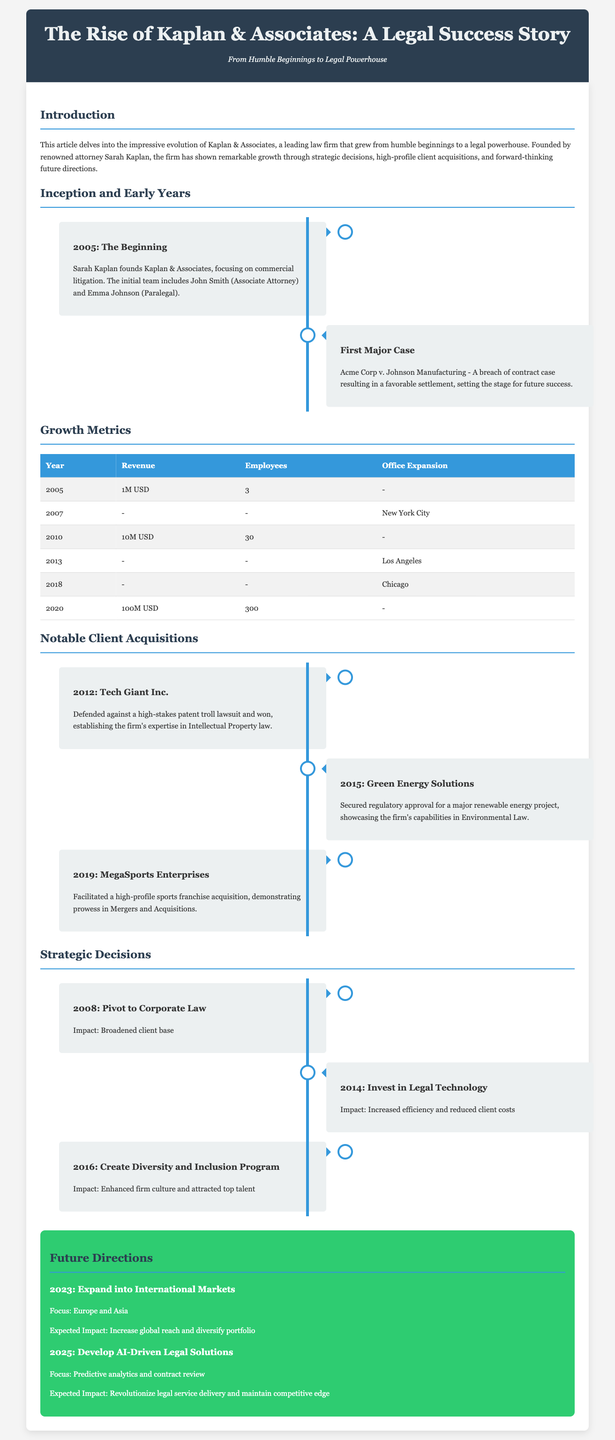What year was Kaplan & Associates founded? The document states that Kaplan & Associates was founded in 2005.
Answer: 2005 Who was the founder of Kaplan & Associates? The document identifies Sarah Kaplan as the founder of the law firm.
Answer: Sarah Kaplan What is the revenue in 2020? According to the provided data, the revenue for the year 2020 was listed as 100M USD.
Answer: 100M USD Which city did Kaplan & Associates expand to in 2007? The document mentions that the firm expanded to New York City in 2007.
Answer: New York City What was the first major case handled by Kaplan & Associates? The first major case mentioned is Acme Corp v. Johnson Manufacturing.
Answer: Acme Corp v. Johnson Manufacturing What strategic decision was made in 2014? In 2014, Kaplan & Associates decided to invest in legal technology.
Answer: Invest in Legal Technology Which client was involved in a patent lawsuit in 2012? The document indicates that Tech Giant Inc. was defended in a high-stakes patent troll lawsuit in 2012.
Answer: Tech Giant Inc What is a planned focus area for expansion in 2023? The document states that the focus for expansion in 2023 is Europe and Asia.
Answer: Europe and Asia What impact did the creation of a Diversity and Inclusion Program have? The document notes that it enhanced firm culture and attracted top talent.
Answer: Enhanced firm culture and attracted top talent 